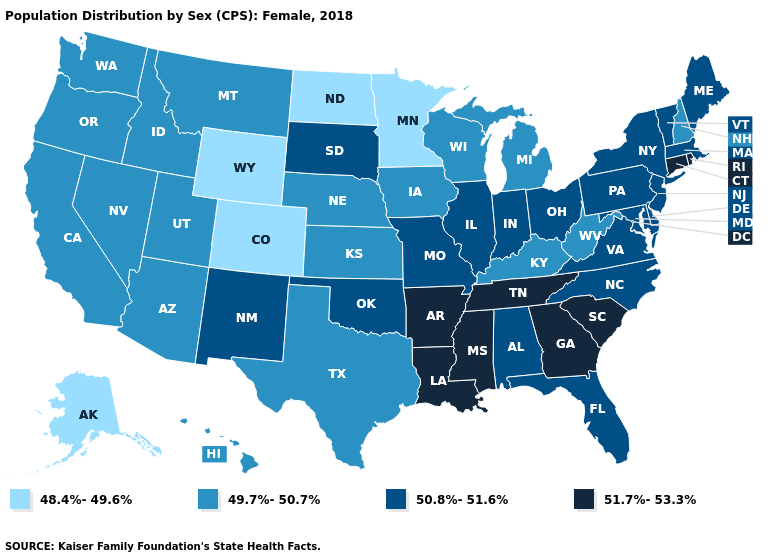Which states have the lowest value in the USA?
Short answer required. Alaska, Colorado, Minnesota, North Dakota, Wyoming. What is the lowest value in the USA?
Quick response, please. 48.4%-49.6%. What is the highest value in the Northeast ?
Be succinct. 51.7%-53.3%. Which states hav the highest value in the Northeast?
Give a very brief answer. Connecticut, Rhode Island. What is the value of Utah?
Give a very brief answer. 49.7%-50.7%. What is the highest value in states that border South Dakota?
Short answer required. 49.7%-50.7%. Does New Hampshire have a higher value than Alaska?
Be succinct. Yes. Name the states that have a value in the range 50.8%-51.6%?
Concise answer only. Alabama, Delaware, Florida, Illinois, Indiana, Maine, Maryland, Massachusetts, Missouri, New Jersey, New Mexico, New York, North Carolina, Ohio, Oklahoma, Pennsylvania, South Dakota, Vermont, Virginia. What is the value of Oregon?
Be succinct. 49.7%-50.7%. Does North Dakota have the lowest value in the USA?
Short answer required. Yes. What is the value of Kansas?
Short answer required. 49.7%-50.7%. Among the states that border Wisconsin , which have the lowest value?
Keep it brief. Minnesota. What is the value of Pennsylvania?
Answer briefly. 50.8%-51.6%. Which states hav the highest value in the Northeast?
Short answer required. Connecticut, Rhode Island. Does California have the highest value in the West?
Give a very brief answer. No. 